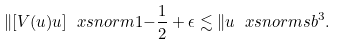Convert formula to latex. <formula><loc_0><loc_0><loc_500><loc_500>\| [ V ( u ) u ] \ x s n o r m { 1 } { - \frac { 1 } { 2 } + \epsilon } \lesssim \| u \ x s n o r m { s } { b } ^ { 3 } .</formula> 